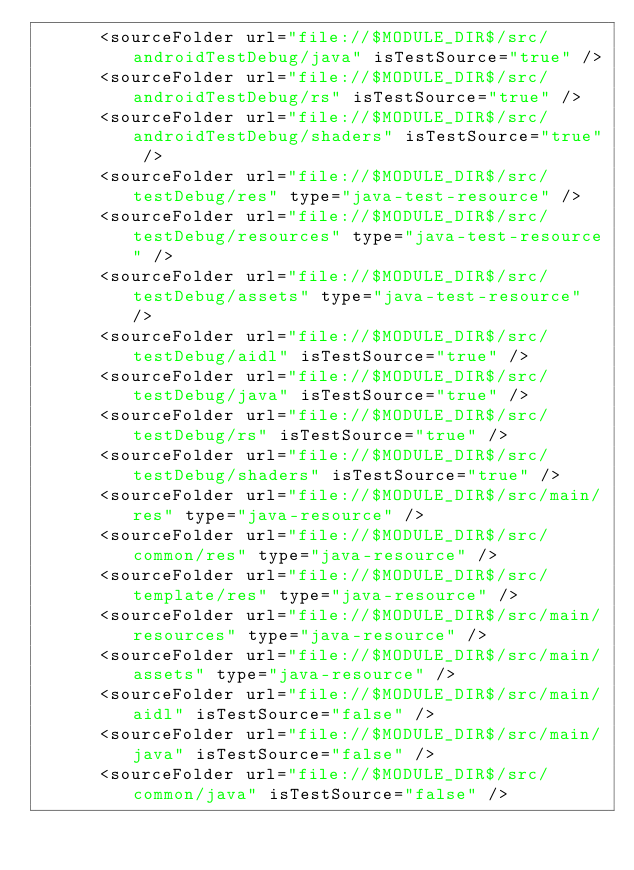Convert code to text. <code><loc_0><loc_0><loc_500><loc_500><_XML_>      <sourceFolder url="file://$MODULE_DIR$/src/androidTestDebug/java" isTestSource="true" />
      <sourceFolder url="file://$MODULE_DIR$/src/androidTestDebug/rs" isTestSource="true" />
      <sourceFolder url="file://$MODULE_DIR$/src/androidTestDebug/shaders" isTestSource="true" />
      <sourceFolder url="file://$MODULE_DIR$/src/testDebug/res" type="java-test-resource" />
      <sourceFolder url="file://$MODULE_DIR$/src/testDebug/resources" type="java-test-resource" />
      <sourceFolder url="file://$MODULE_DIR$/src/testDebug/assets" type="java-test-resource" />
      <sourceFolder url="file://$MODULE_DIR$/src/testDebug/aidl" isTestSource="true" />
      <sourceFolder url="file://$MODULE_DIR$/src/testDebug/java" isTestSource="true" />
      <sourceFolder url="file://$MODULE_DIR$/src/testDebug/rs" isTestSource="true" />
      <sourceFolder url="file://$MODULE_DIR$/src/testDebug/shaders" isTestSource="true" />
      <sourceFolder url="file://$MODULE_DIR$/src/main/res" type="java-resource" />
      <sourceFolder url="file://$MODULE_DIR$/src/common/res" type="java-resource" />
      <sourceFolder url="file://$MODULE_DIR$/src/template/res" type="java-resource" />
      <sourceFolder url="file://$MODULE_DIR$/src/main/resources" type="java-resource" />
      <sourceFolder url="file://$MODULE_DIR$/src/main/assets" type="java-resource" />
      <sourceFolder url="file://$MODULE_DIR$/src/main/aidl" isTestSource="false" />
      <sourceFolder url="file://$MODULE_DIR$/src/main/java" isTestSource="false" />
      <sourceFolder url="file://$MODULE_DIR$/src/common/java" isTestSource="false" /></code> 